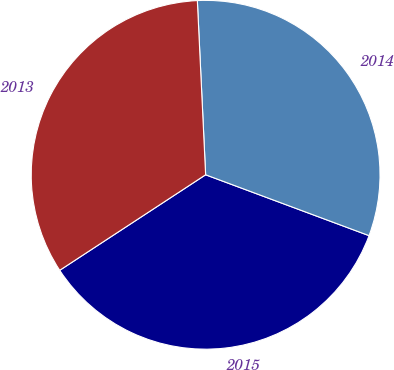Convert chart. <chart><loc_0><loc_0><loc_500><loc_500><pie_chart><fcel>2015<fcel>2014<fcel>2013<nl><fcel>35.1%<fcel>31.43%<fcel>33.47%<nl></chart> 